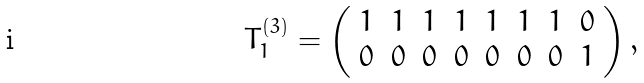<formula> <loc_0><loc_0><loc_500><loc_500>T _ { 1 } ^ { ( 3 ) } = \left ( \begin{array} { c c c c c c c c } 1 & 1 & 1 & 1 & 1 & 1 & 1 & 0 \\ 0 & 0 & 0 & 0 & 0 & 0 & 0 & 1 \end{array} \right ) ,</formula> 